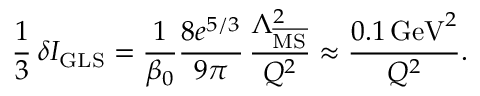Convert formula to latex. <formula><loc_0><loc_0><loc_500><loc_500>\frac { 1 } { 3 } \, \delta I _ { G L S } = \frac { 1 } { \beta _ { 0 } } \frac { 8 e ^ { 5 / 3 } } { 9 \pi } \, \frac { \Lambda _ { \overline { M S } } ^ { 2 } } { Q ^ { 2 } } \approx \frac { 0 . 1 \, G e V ^ { 2 } } { Q ^ { 2 } } .</formula> 